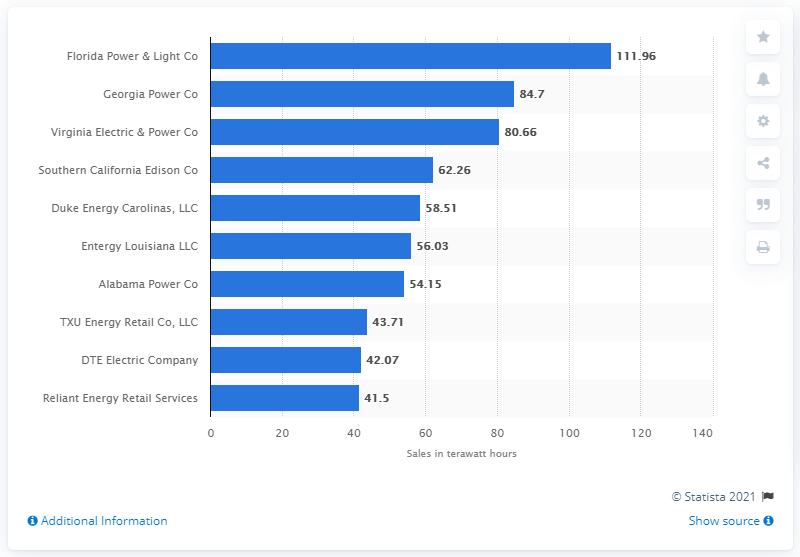Identify some key points in this picture. Georgia Power Company is the second largest utility in the United States. 